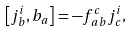<formula> <loc_0><loc_0><loc_500><loc_500>\left [ j _ { b } ^ { i } , b _ { a } \right ] = - f _ { \, a b } ^ { c } j _ { c } ^ { i } ,</formula> 